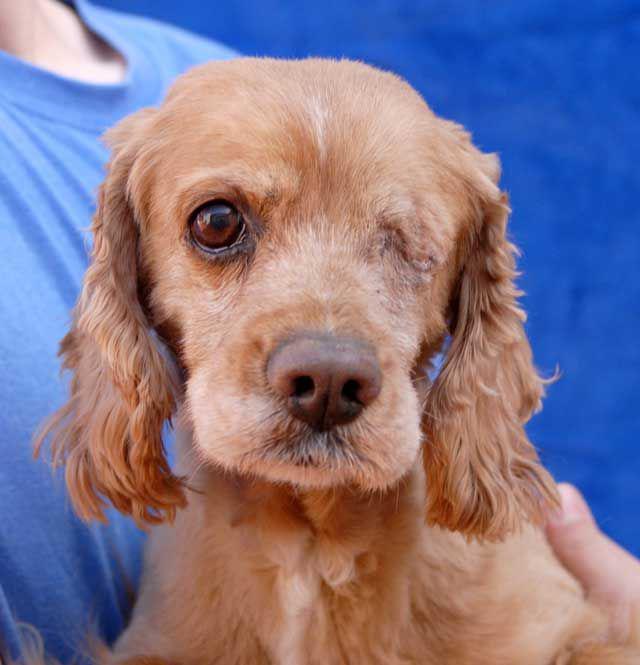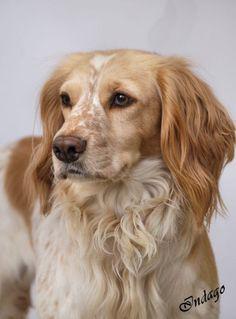The first image is the image on the left, the second image is the image on the right. Considering the images on both sides, is "the dog on the right image is facing right" valid? Answer yes or no. No. 